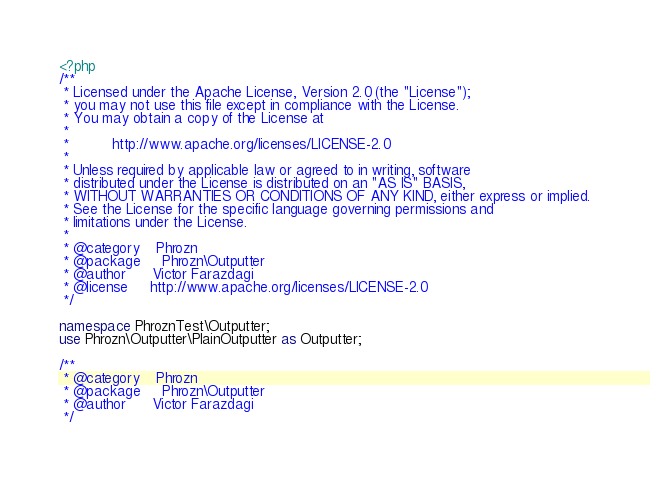<code> <loc_0><loc_0><loc_500><loc_500><_PHP_><?php
/**
 * Licensed under the Apache License, Version 2.0 (the "License");
 * you may not use this file except in compliance with the License.
 * You may obtain a copy of the License at
 *
 *          http://www.apache.org/licenses/LICENSE-2.0
 *
 * Unless required by applicable law or agreed to in writing, software
 * distributed under the License is distributed on an "AS IS" BASIS,
 * WITHOUT WARRANTIES OR CONDITIONS OF ANY KIND, either express or implied.
 * See the License for the specific language governing permissions and
 * limitations under the License.
 *
 * @category    Phrozn
 * @package     Phrozn\Outputter
 * @author      Victor Farazdagi
 * @license     http://www.apache.org/licenses/LICENSE-2.0
 */

namespace PhroznTest\Outputter;
use Phrozn\Outputter\PlainOutputter as Outputter;

/**
 * @category    Phrozn
 * @package     Phrozn\Outputter
 * @author      Victor Farazdagi
 */</code> 